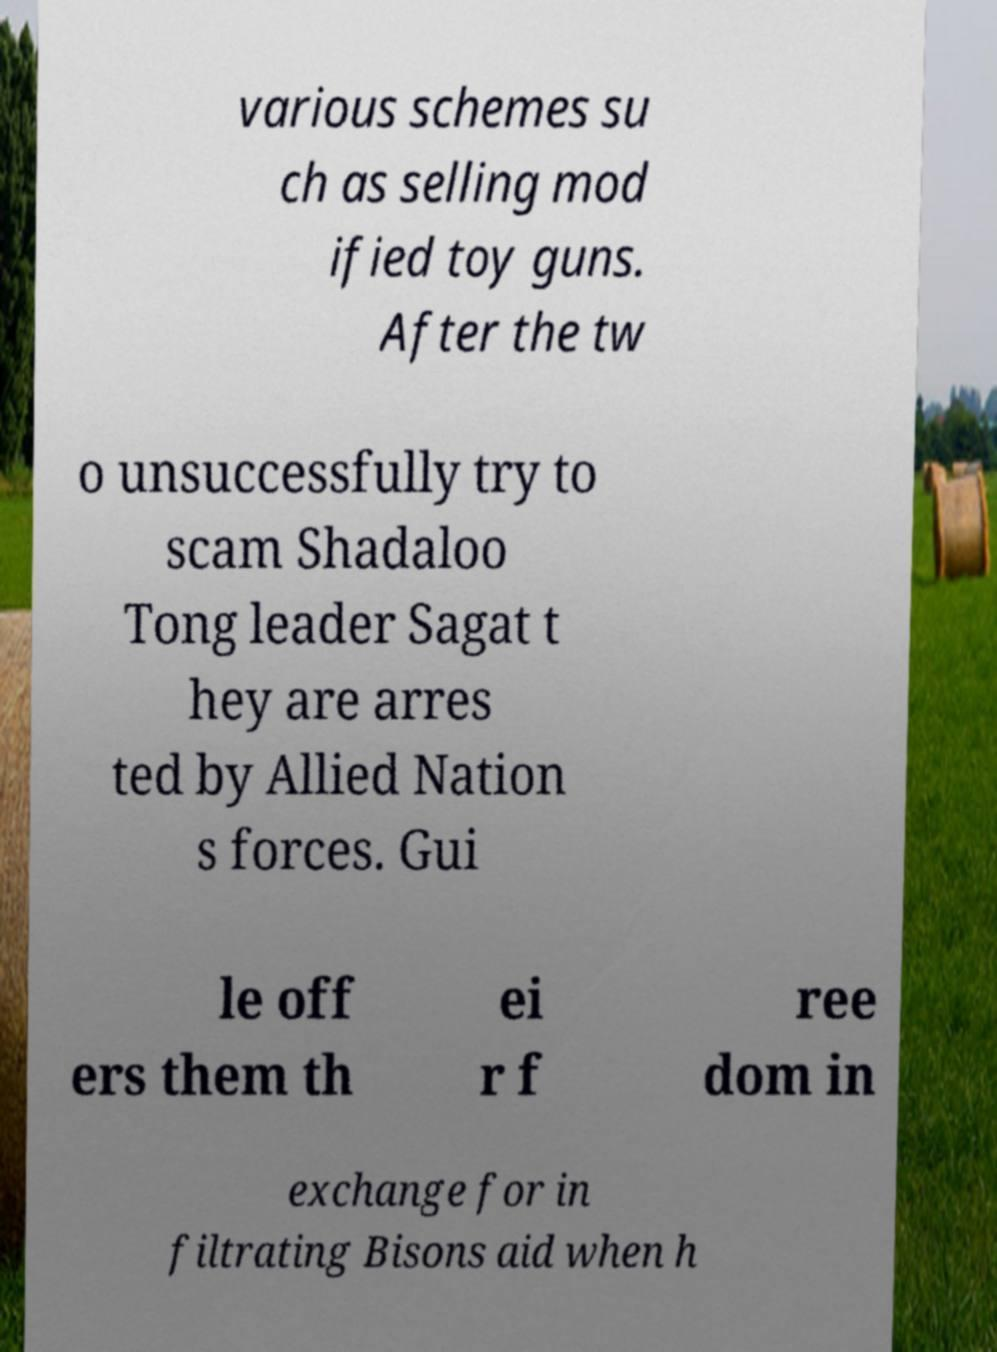I need the written content from this picture converted into text. Can you do that? various schemes su ch as selling mod ified toy guns. After the tw o unsuccessfully try to scam Shadaloo Tong leader Sagat t hey are arres ted by Allied Nation s forces. Gui le off ers them th ei r f ree dom in exchange for in filtrating Bisons aid when h 